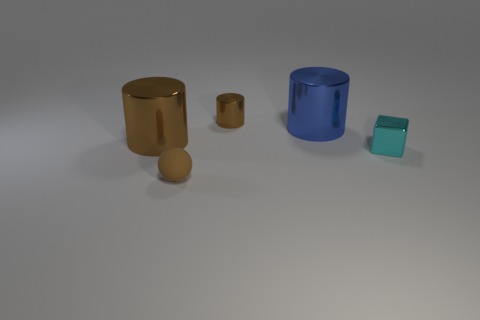Add 4 large cyan balls. How many objects exist? 9 Subtract all cylinders. How many objects are left? 2 Subtract 0 purple cylinders. How many objects are left? 5 Subtract all small blue spheres. Subtract all tiny shiny things. How many objects are left? 3 Add 2 big cylinders. How many big cylinders are left? 4 Add 2 small cyan spheres. How many small cyan spheres exist? 2 